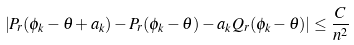<formula> <loc_0><loc_0><loc_500><loc_500>\left | P _ { r } ( \phi _ { k } - \theta + a _ { k } ) - P _ { r } ( \phi _ { k } - \theta ) - a _ { k } Q _ { r } ( \phi _ { k } - \theta ) \right | \leq \frac { C } { n ^ { 2 } }</formula> 